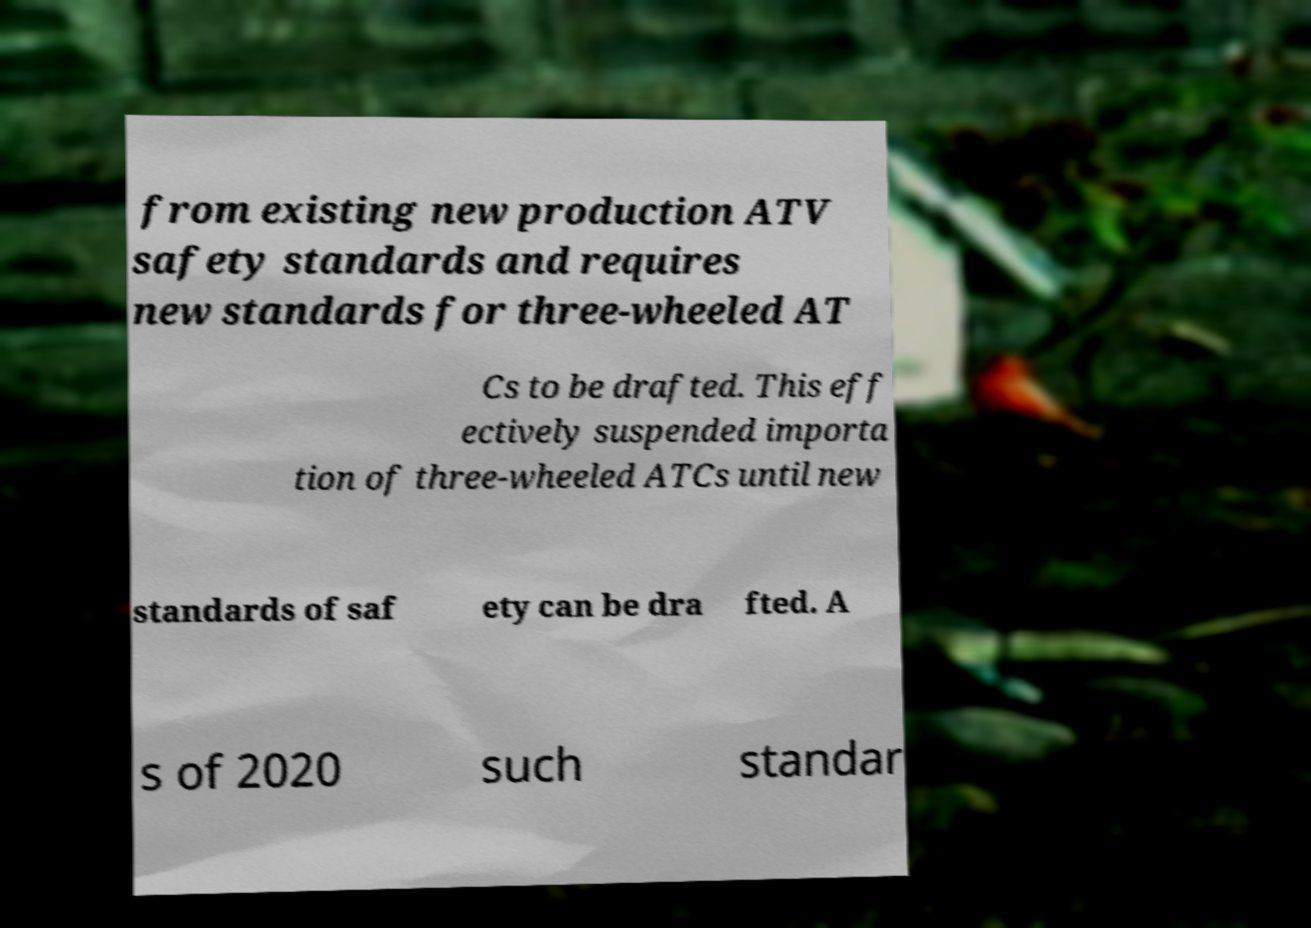For documentation purposes, I need the text within this image transcribed. Could you provide that? from existing new production ATV safety standards and requires new standards for three-wheeled AT Cs to be drafted. This eff ectively suspended importa tion of three-wheeled ATCs until new standards of saf ety can be dra fted. A s of 2020 such standar 